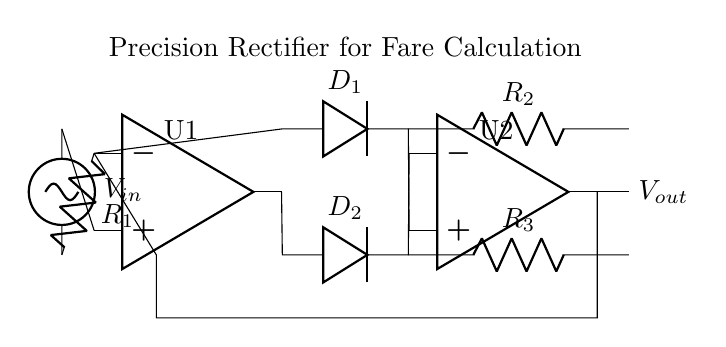What is the function of D1 in this circuit? D1 is a diode that allows current to flow in one direction, specifically the positive half of the input signal, thus contributing to the voltage rectification process.
Answer: Diode What are the values of the resistors in the circuit? The circuit features three resistors labeled as R1, R2, and R3; the specific numerical values are not given in the diagram but are critical for setting the gain of the operational amplifiers.
Answer: Not specified How many operational amplifiers are used in this circuit? The diagram displays two operational amplifiers (U1 and U2), which are essential components for creating a precision rectifier that accurately processes the input voltage.
Answer: Two What happens to the signal at the output (Vout)? At the output Vout, the signal is a rectified version of the input signal, reflecting only the positive magnitude of the input voltage due to the operation of the diodes and the feedback structure of the amplifiers.
Answer: Rectified signal What is the role of feedback in this circuit? Feedback connects the output of the second operational amplifier back to the input of the first operational amplifier, allowing for improved accuracy and stability in the rectification process by controlling the operation of U1.
Answer: Accuracy What type of rectifier is represented in this circuit? The circuit represents a precision rectifier, which is designed to provide accurate results even for low-level input signals, often necessary in applications like fare calculation in ticket vending machines.
Answer: Precision rectifier 